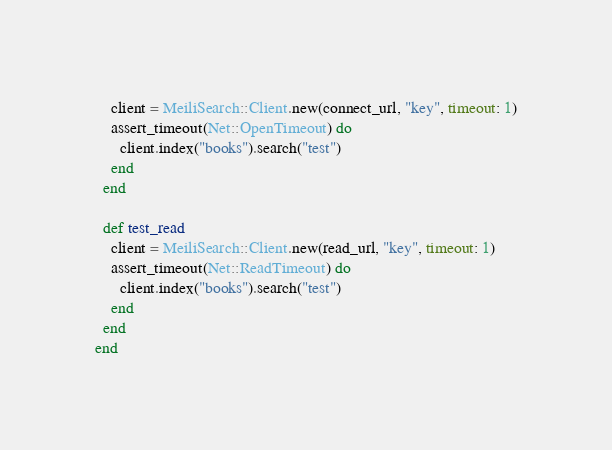Convert code to text. <code><loc_0><loc_0><loc_500><loc_500><_Ruby_>    client = MeiliSearch::Client.new(connect_url, "key", timeout: 1)
    assert_timeout(Net::OpenTimeout) do
      client.index("books").search("test")
    end
  end

  def test_read
    client = MeiliSearch::Client.new(read_url, "key", timeout: 1)
    assert_timeout(Net::ReadTimeout) do
      client.index("books").search("test")
    end
  end
end
</code> 